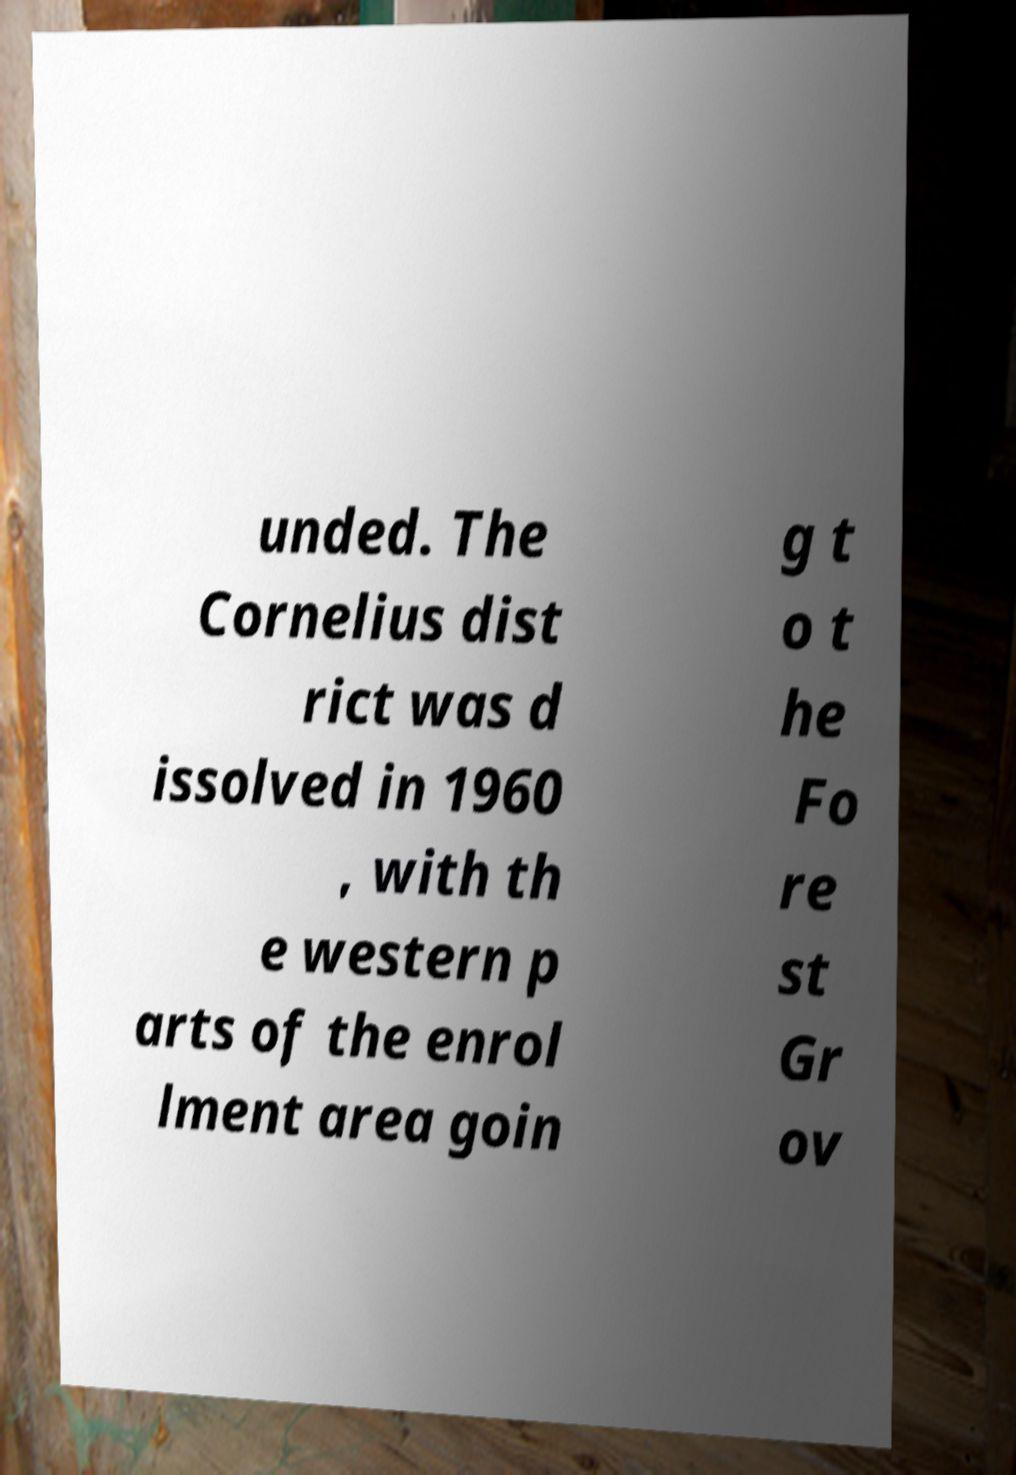Can you accurately transcribe the text from the provided image for me? unded. The Cornelius dist rict was d issolved in 1960 , with th e western p arts of the enrol lment area goin g t o t he Fo re st Gr ov 